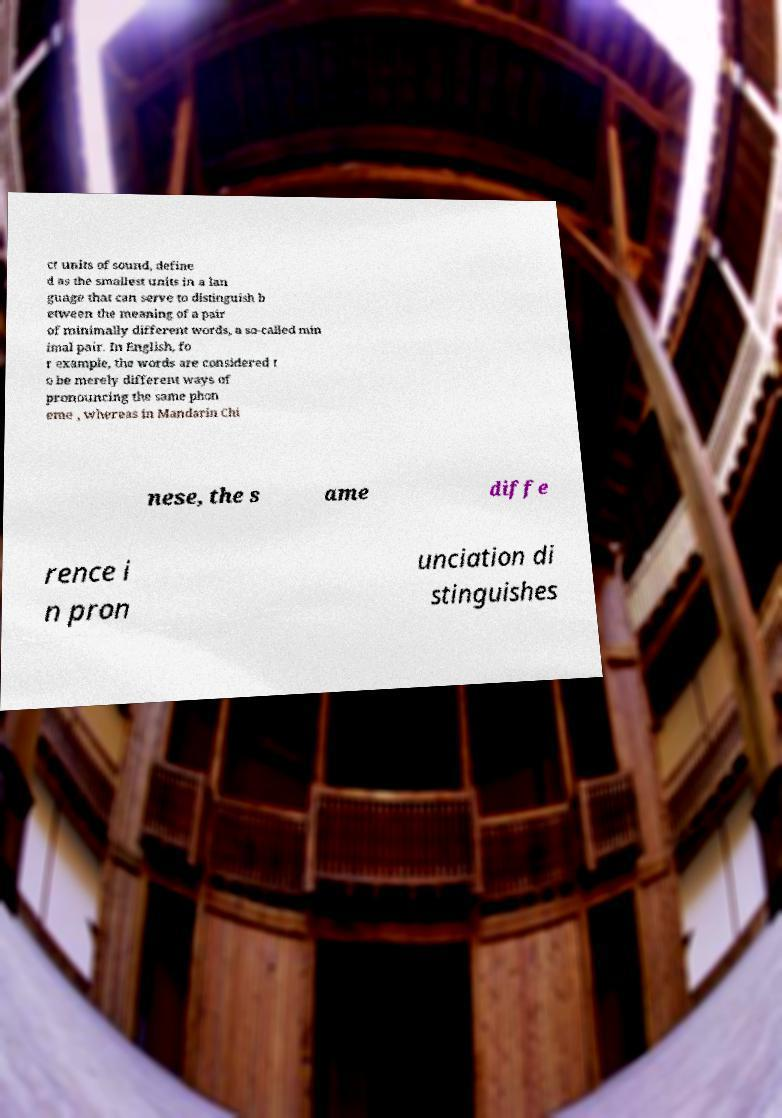Can you read and provide the text displayed in the image?This photo seems to have some interesting text. Can you extract and type it out for me? ct units of sound, define d as the smallest units in a lan guage that can serve to distinguish b etween the meaning of a pair of minimally different words, a so-called min imal pair. In English, fo r example, the words are considered t o be merely different ways of pronouncing the same phon eme , whereas in Mandarin Chi nese, the s ame diffe rence i n pron unciation di stinguishes 